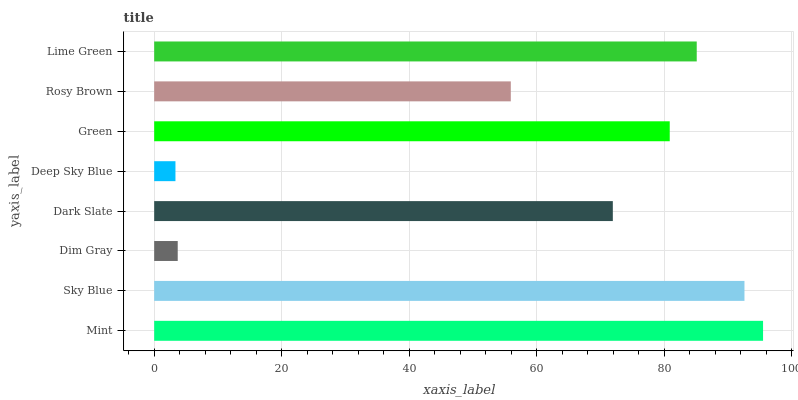Is Deep Sky Blue the minimum?
Answer yes or no. Yes. Is Mint the maximum?
Answer yes or no. Yes. Is Sky Blue the minimum?
Answer yes or no. No. Is Sky Blue the maximum?
Answer yes or no. No. Is Mint greater than Sky Blue?
Answer yes or no. Yes. Is Sky Blue less than Mint?
Answer yes or no. Yes. Is Sky Blue greater than Mint?
Answer yes or no. No. Is Mint less than Sky Blue?
Answer yes or no. No. Is Green the high median?
Answer yes or no. Yes. Is Dark Slate the low median?
Answer yes or no. Yes. Is Rosy Brown the high median?
Answer yes or no. No. Is Green the low median?
Answer yes or no. No. 